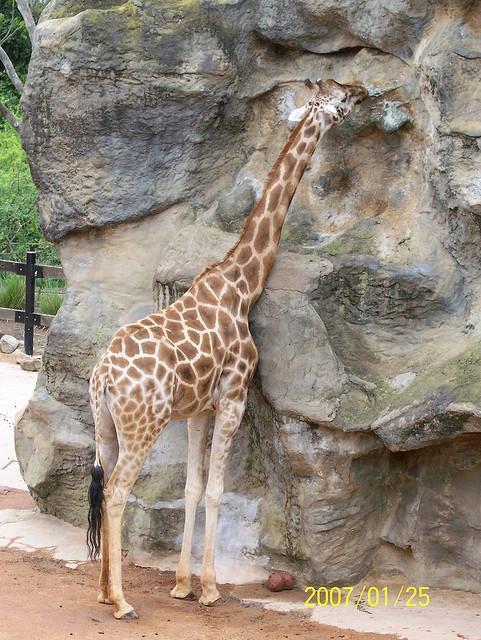How many animals are in this picture?
Give a very brief answer. 1. How many people are in the pic?
Give a very brief answer. 0. 